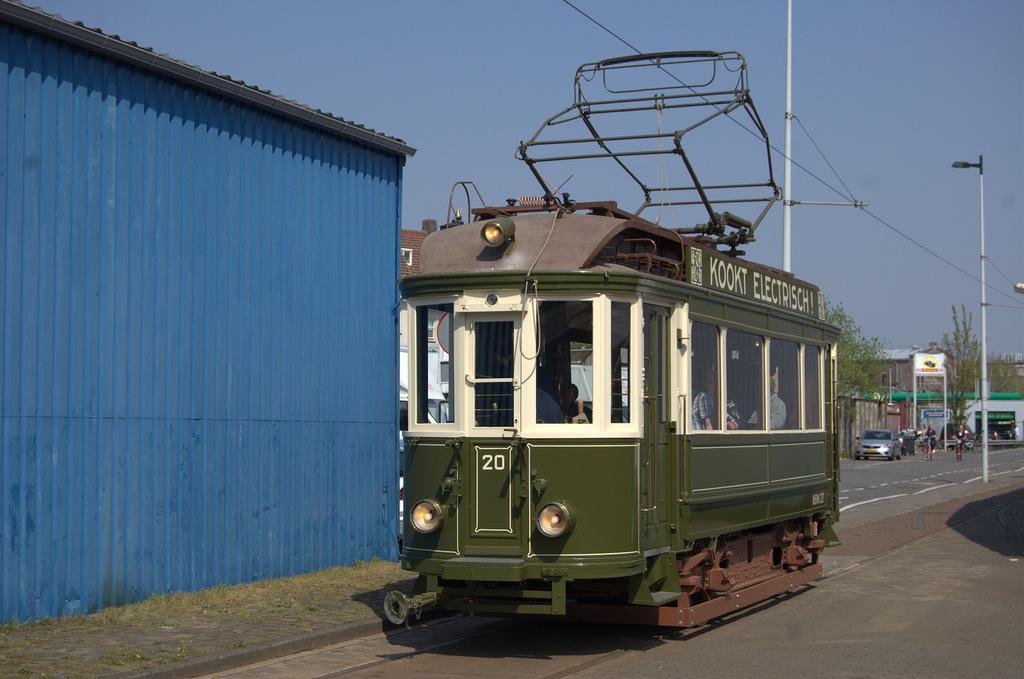Describe this image in one or two sentences. In this image we can see the passing electric train with some people. We can also see the houses, trees, light poles, wires and also the vehicles on the road. We can also see the hoarding, grass, path and also the sky. 